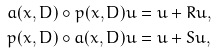<formula> <loc_0><loc_0><loc_500><loc_500>a ( x , D ) \circ p ( x , D ) u & = u + R u , \\ p ( x , D ) \circ a ( x , D ) u & = u + S u ,</formula> 